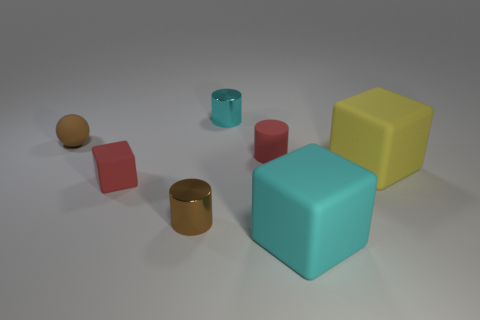Are there more brown cylinders behind the small brown metallic cylinder than big blue things?
Make the answer very short. No. There is a red object that is on the left side of the tiny metallic thing that is behind the big yellow matte cube; what number of small cubes are on the left side of it?
Offer a terse response. 0. Does the brown thing that is in front of the tiny rubber cube have the same shape as the brown matte thing?
Offer a very short reply. No. There is a brown thing that is on the right side of the matte ball; what material is it?
Ensure brevity in your answer.  Metal. There is a tiny rubber thing that is left of the tiny cyan cylinder and behind the small matte cube; what shape is it?
Offer a very short reply. Sphere. What material is the large cyan block?
Provide a succinct answer. Rubber. What number of cylinders are big yellow objects or brown shiny things?
Your answer should be compact. 1. Does the brown cylinder have the same material as the yellow block?
Provide a short and direct response. No. The red matte thing that is the same shape as the yellow object is what size?
Offer a very short reply. Small. What is the material of the tiny thing that is both right of the tiny rubber block and in front of the yellow object?
Make the answer very short. Metal. 